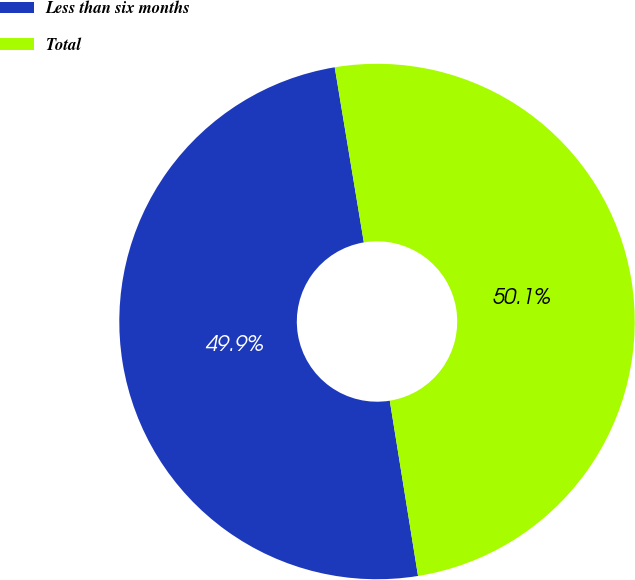<chart> <loc_0><loc_0><loc_500><loc_500><pie_chart><fcel>Less than six months<fcel>Total<nl><fcel>49.92%<fcel>50.08%<nl></chart> 